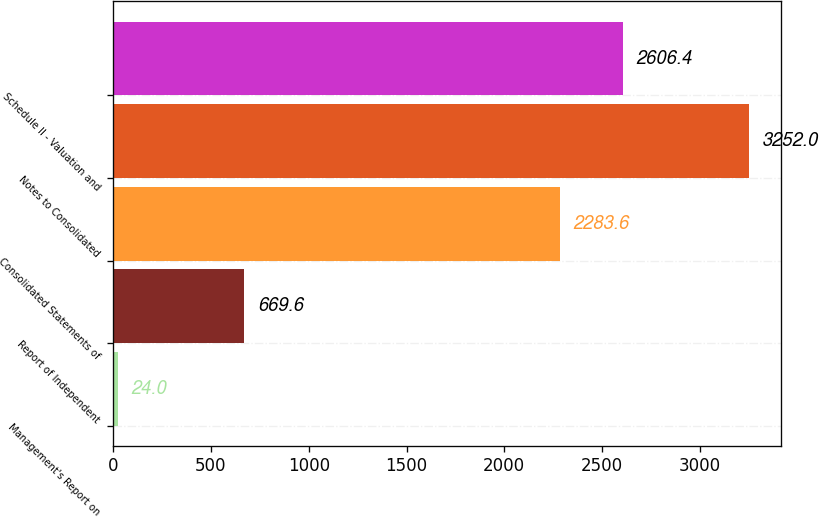Convert chart to OTSL. <chart><loc_0><loc_0><loc_500><loc_500><bar_chart><fcel>Management's Report on<fcel>Report of Independent<fcel>Consolidated Statements of<fcel>Notes to Consolidated<fcel>Schedule II - Valuation and<nl><fcel>24<fcel>669.6<fcel>2283.6<fcel>3252<fcel>2606.4<nl></chart> 